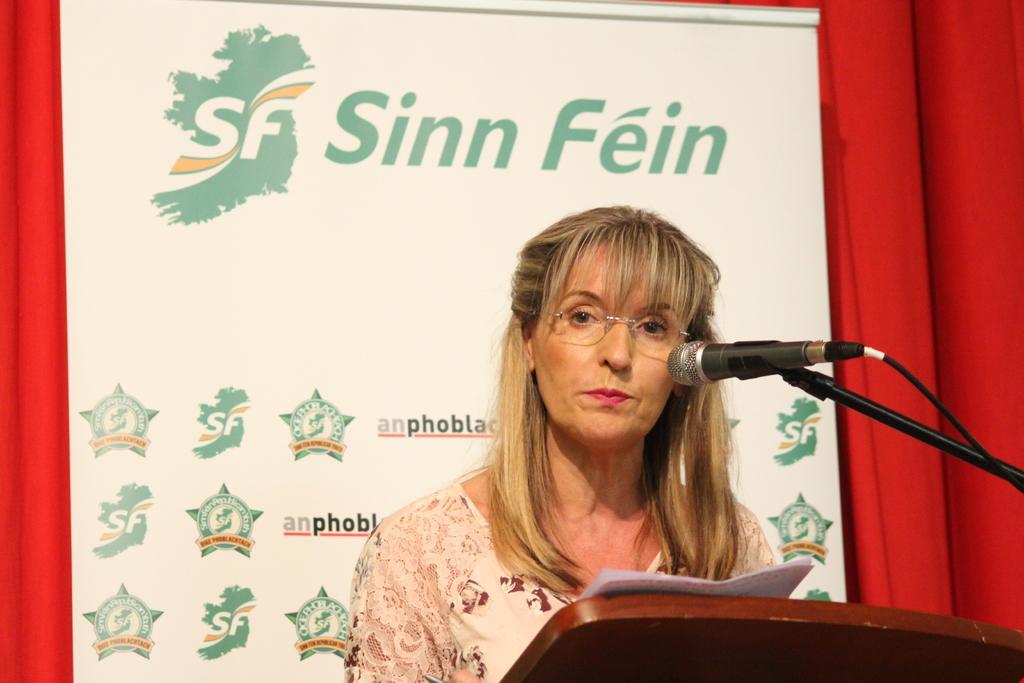Please provide a concise description of this image. In this picture, it looks like a podium and on the podium there are papers and a microphone with the stand and a cable. A woman is standing behind the podium. Behind the woman there is a board and a red color object. 